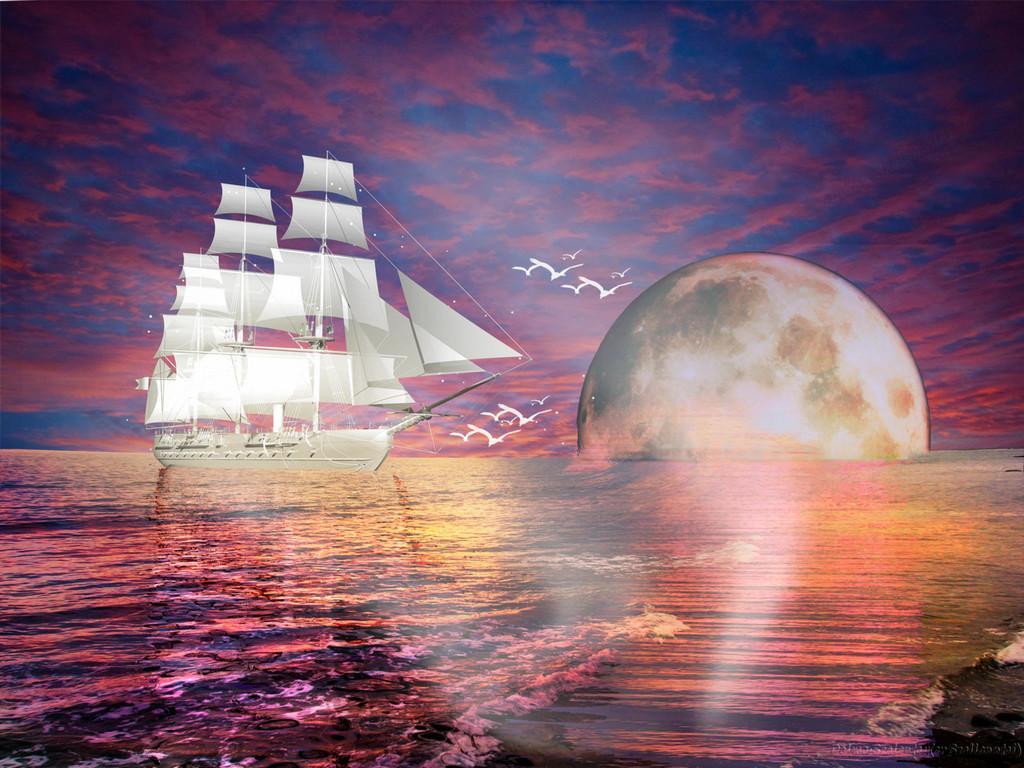In one or two sentences, can you explain what this image depicts? This is an animated image on which we can see there is a ship on the water and sun going down. 